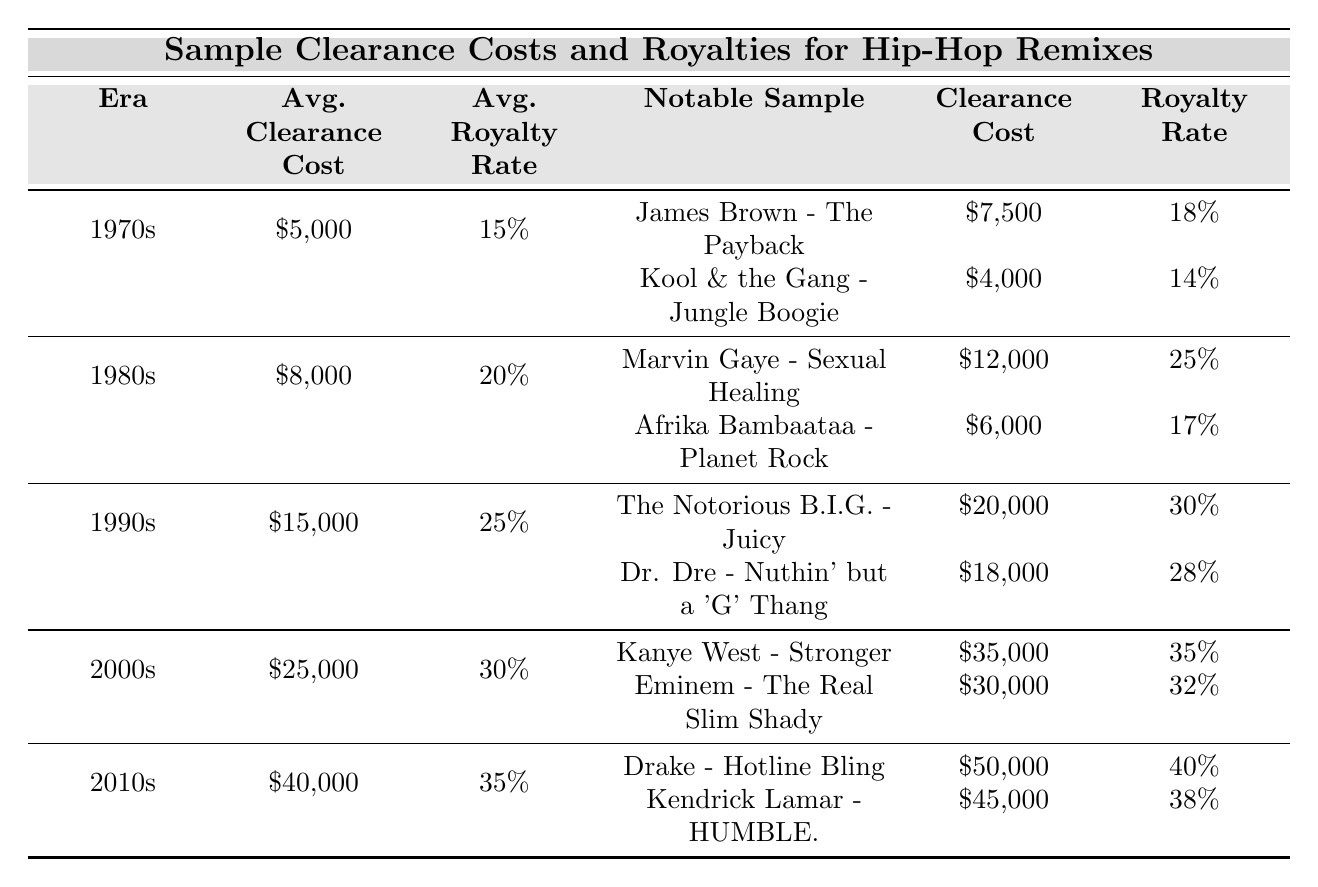What is the average sample clearance cost for the 1990s? The table states that the average sample clearance cost for the 1990s is listed in the corresponding row, which shows $15,000.
Answer: $15,000 Which notable sample from the 2000s has the highest clearance cost? In the 2000s row, there are two notable samples: Kanye West's "Stronger" with a clearance cost of $35,000 and Eminem's "The Real Slim Shady" with a clearance cost of $30,000. Comparing these values, Kanye West's "Stronger" has the highest clearance cost.
Answer: Kanye West's "Stronger" What is the difference in average royalty rates between the 1980s and 2000s? The average royalty rate for the 1980s is 20%, and for the 2000s, it is 30%. The difference is calculated as 30% - 20% = 10%.
Answer: 10% Which era has both the highest average sample clearance cost and the highest average royalty rate? The table shows that the 2010s has the highest average sample clearance cost of $40,000 and an average royalty rate of 35%. Comparing with other eras, no other era has both a higher clearance cost and royalty rate.
Answer: 2010s Is the sample clearance cost for Marvin Gaye's "Sexual Healing" greater than the average clearance cost for the 1980s? Marvin Gaye's "Sexual Healing" has a clearance cost of $12,000. The average clearance cost for the 1980s is $8,000. Since $12,000 is greater than $8,000, the statement is true.
Answer: Yes What is the average of the clearance costs for notable samples from the 1970s? The notable samples in the 1970s are James Brown's "The Payback" at $7,500 and Kool & the Gang's "Jungle Boogie" at $4,000. To calculate the average, sum the clearance costs $7,500 + $4,000 = $11,500 and divide by 2, which results in $11,500 / 2 = $5,750.
Answer: $5,750 Which decade had the lowest average sample clearance cost? By examining the table, the 1970s has an average sample clearance cost of $5,000, which is lower than all the other decades listed.
Answer: 1970s What is the total clearance cost for both notable samples from the 2010s? The notable samples from the 2010s are Drake's "Hotline Bling" at $50,000 and Kendrick Lamar's "HUMBLE." at $45,000. Adding these numbers together gives $50,000 + $45,000 = $95,000.
Answer: $95,000 Are the royalty rates for the 1990s higher than for the 1980s? The average royalty rate for the 1990s is 25%, while for the 1980s it is 20%. Since 25% is greater than 20%, the statement is true.
Answer: Yes What is the highest sample clearance cost among notable samples from the table? The table shows multiple notable samples, with Kanye West's "Stronger" at $35,000 being the highest clearance cost when compared to all other samples listed.
Answer: $35,000 